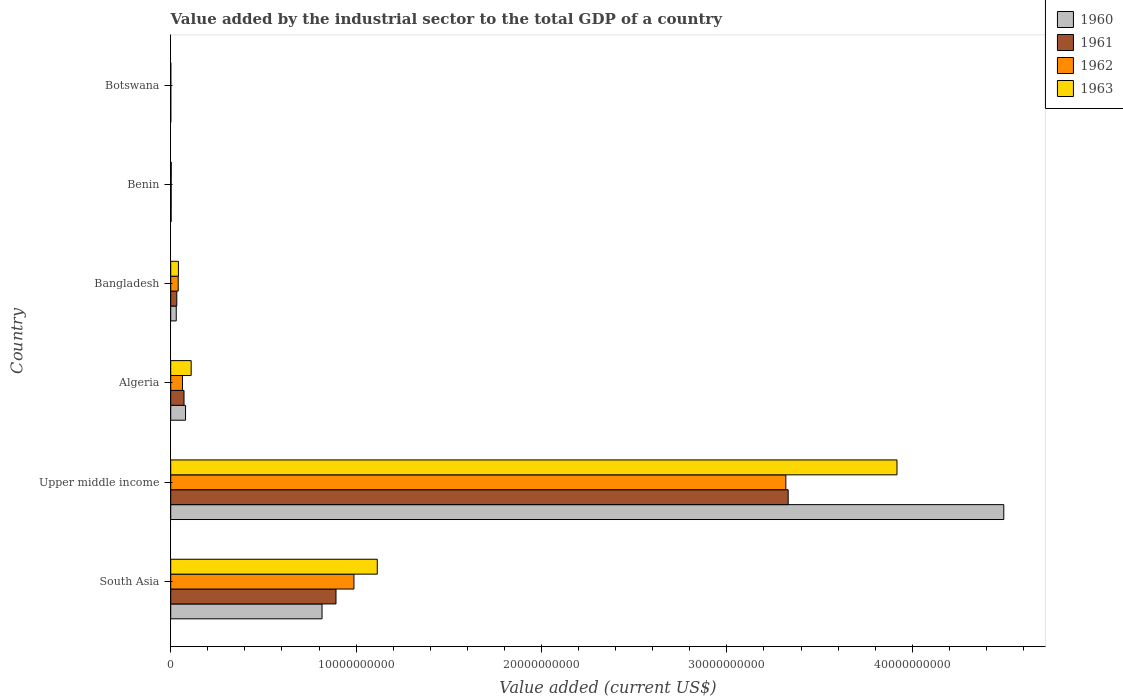How many different coloured bars are there?
Ensure brevity in your answer.  4. How many groups of bars are there?
Your answer should be compact. 6. Are the number of bars per tick equal to the number of legend labels?
Keep it short and to the point. Yes. Are the number of bars on each tick of the Y-axis equal?
Provide a short and direct response. Yes. How many bars are there on the 6th tick from the bottom?
Ensure brevity in your answer.  4. What is the value added by the industrial sector to the total GDP in 1963 in Bangladesh?
Make the answer very short. 4.15e+08. Across all countries, what is the maximum value added by the industrial sector to the total GDP in 1962?
Provide a succinct answer. 3.32e+1. Across all countries, what is the minimum value added by the industrial sector to the total GDP in 1962?
Your answer should be very brief. 4.05e+06. In which country was the value added by the industrial sector to the total GDP in 1960 maximum?
Your answer should be very brief. Upper middle income. In which country was the value added by the industrial sector to the total GDP in 1962 minimum?
Offer a terse response. Botswana. What is the total value added by the industrial sector to the total GDP in 1962 in the graph?
Your response must be concise. 4.41e+1. What is the difference between the value added by the industrial sector to the total GDP in 1963 in South Asia and that in Upper middle income?
Offer a very short reply. -2.80e+1. What is the difference between the value added by the industrial sector to the total GDP in 1963 in South Asia and the value added by the industrial sector to the total GDP in 1962 in Algeria?
Give a very brief answer. 1.05e+1. What is the average value added by the industrial sector to the total GDP in 1961 per country?
Your response must be concise. 7.22e+09. What is the difference between the value added by the industrial sector to the total GDP in 1961 and value added by the industrial sector to the total GDP in 1962 in Botswana?
Give a very brief answer. -8106.08. In how many countries, is the value added by the industrial sector to the total GDP in 1961 greater than 26000000000 US$?
Provide a short and direct response. 1. What is the ratio of the value added by the industrial sector to the total GDP in 1963 in Algeria to that in South Asia?
Offer a very short reply. 0.1. Is the value added by the industrial sector to the total GDP in 1962 in South Asia less than that in Upper middle income?
Offer a very short reply. Yes. What is the difference between the highest and the second highest value added by the industrial sector to the total GDP in 1962?
Keep it short and to the point. 2.33e+1. What is the difference between the highest and the lowest value added by the industrial sector to the total GDP in 1960?
Your answer should be very brief. 4.49e+1. In how many countries, is the value added by the industrial sector to the total GDP in 1962 greater than the average value added by the industrial sector to the total GDP in 1962 taken over all countries?
Ensure brevity in your answer.  2. Is it the case that in every country, the sum of the value added by the industrial sector to the total GDP in 1962 and value added by the industrial sector to the total GDP in 1961 is greater than the sum of value added by the industrial sector to the total GDP in 1963 and value added by the industrial sector to the total GDP in 1960?
Offer a terse response. No. What does the 2nd bar from the bottom in Botswana represents?
Offer a very short reply. 1961. How many bars are there?
Provide a short and direct response. 24. Are all the bars in the graph horizontal?
Provide a succinct answer. Yes. Does the graph contain any zero values?
Keep it short and to the point. No. How many legend labels are there?
Offer a very short reply. 4. What is the title of the graph?
Make the answer very short. Value added by the industrial sector to the total GDP of a country. What is the label or title of the X-axis?
Your answer should be very brief. Value added (current US$). What is the Value added (current US$) of 1960 in South Asia?
Make the answer very short. 8.16e+09. What is the Value added (current US$) in 1961 in South Asia?
Give a very brief answer. 8.91e+09. What is the Value added (current US$) of 1962 in South Asia?
Keep it short and to the point. 9.88e+09. What is the Value added (current US$) of 1963 in South Asia?
Offer a terse response. 1.11e+1. What is the Value added (current US$) of 1960 in Upper middle income?
Offer a terse response. 4.49e+1. What is the Value added (current US$) in 1961 in Upper middle income?
Ensure brevity in your answer.  3.33e+1. What is the Value added (current US$) in 1962 in Upper middle income?
Make the answer very short. 3.32e+1. What is the Value added (current US$) of 1963 in Upper middle income?
Your answer should be compact. 3.92e+1. What is the Value added (current US$) in 1960 in Algeria?
Give a very brief answer. 8.00e+08. What is the Value added (current US$) in 1961 in Algeria?
Ensure brevity in your answer.  7.17e+08. What is the Value added (current US$) of 1962 in Algeria?
Keep it short and to the point. 6.34e+08. What is the Value added (current US$) in 1963 in Algeria?
Make the answer very short. 1.10e+09. What is the Value added (current US$) in 1960 in Bangladesh?
Your answer should be compact. 2.98e+08. What is the Value added (current US$) in 1961 in Bangladesh?
Ensure brevity in your answer.  3.27e+08. What is the Value added (current US$) in 1962 in Bangladesh?
Offer a terse response. 4.05e+08. What is the Value added (current US$) in 1963 in Bangladesh?
Offer a very short reply. 4.15e+08. What is the Value added (current US$) in 1960 in Benin?
Ensure brevity in your answer.  2.31e+07. What is the Value added (current US$) of 1961 in Benin?
Provide a succinct answer. 2.31e+07. What is the Value added (current US$) in 1962 in Benin?
Give a very brief answer. 2.32e+07. What is the Value added (current US$) of 1963 in Benin?
Give a very brief answer. 2.91e+07. What is the Value added (current US$) in 1960 in Botswana?
Your response must be concise. 4.05e+06. What is the Value added (current US$) of 1961 in Botswana?
Your answer should be compact. 4.05e+06. What is the Value added (current US$) in 1962 in Botswana?
Provide a succinct answer. 4.05e+06. What is the Value added (current US$) of 1963 in Botswana?
Ensure brevity in your answer.  4.04e+06. Across all countries, what is the maximum Value added (current US$) in 1960?
Provide a succinct answer. 4.49e+1. Across all countries, what is the maximum Value added (current US$) of 1961?
Make the answer very short. 3.33e+1. Across all countries, what is the maximum Value added (current US$) in 1962?
Offer a terse response. 3.32e+1. Across all countries, what is the maximum Value added (current US$) in 1963?
Give a very brief answer. 3.92e+1. Across all countries, what is the minimum Value added (current US$) of 1960?
Give a very brief answer. 4.05e+06. Across all countries, what is the minimum Value added (current US$) of 1961?
Make the answer very short. 4.05e+06. Across all countries, what is the minimum Value added (current US$) of 1962?
Make the answer very short. 4.05e+06. Across all countries, what is the minimum Value added (current US$) of 1963?
Offer a terse response. 4.04e+06. What is the total Value added (current US$) of 1960 in the graph?
Give a very brief answer. 5.42e+1. What is the total Value added (current US$) of 1961 in the graph?
Provide a short and direct response. 4.33e+1. What is the total Value added (current US$) of 1962 in the graph?
Ensure brevity in your answer.  4.41e+1. What is the total Value added (current US$) of 1963 in the graph?
Provide a succinct answer. 5.19e+1. What is the difference between the Value added (current US$) of 1960 in South Asia and that in Upper middle income?
Your answer should be compact. -3.68e+1. What is the difference between the Value added (current US$) of 1961 in South Asia and that in Upper middle income?
Keep it short and to the point. -2.44e+1. What is the difference between the Value added (current US$) in 1962 in South Asia and that in Upper middle income?
Your answer should be very brief. -2.33e+1. What is the difference between the Value added (current US$) in 1963 in South Asia and that in Upper middle income?
Provide a succinct answer. -2.80e+1. What is the difference between the Value added (current US$) in 1960 in South Asia and that in Algeria?
Your answer should be compact. 7.36e+09. What is the difference between the Value added (current US$) in 1961 in South Asia and that in Algeria?
Provide a succinct answer. 8.20e+09. What is the difference between the Value added (current US$) of 1962 in South Asia and that in Algeria?
Your answer should be very brief. 9.25e+09. What is the difference between the Value added (current US$) in 1963 in South Asia and that in Algeria?
Give a very brief answer. 1.00e+1. What is the difference between the Value added (current US$) of 1960 in South Asia and that in Bangladesh?
Your answer should be very brief. 7.86e+09. What is the difference between the Value added (current US$) in 1961 in South Asia and that in Bangladesh?
Your response must be concise. 8.59e+09. What is the difference between the Value added (current US$) in 1962 in South Asia and that in Bangladesh?
Provide a succinct answer. 9.48e+09. What is the difference between the Value added (current US$) of 1963 in South Asia and that in Bangladesh?
Your response must be concise. 1.07e+1. What is the difference between the Value added (current US$) in 1960 in South Asia and that in Benin?
Ensure brevity in your answer.  8.14e+09. What is the difference between the Value added (current US$) in 1961 in South Asia and that in Benin?
Keep it short and to the point. 8.89e+09. What is the difference between the Value added (current US$) of 1962 in South Asia and that in Benin?
Keep it short and to the point. 9.86e+09. What is the difference between the Value added (current US$) of 1963 in South Asia and that in Benin?
Provide a short and direct response. 1.11e+1. What is the difference between the Value added (current US$) in 1960 in South Asia and that in Botswana?
Give a very brief answer. 8.16e+09. What is the difference between the Value added (current US$) of 1961 in South Asia and that in Botswana?
Provide a succinct answer. 8.91e+09. What is the difference between the Value added (current US$) in 1962 in South Asia and that in Botswana?
Provide a short and direct response. 9.88e+09. What is the difference between the Value added (current US$) of 1963 in South Asia and that in Botswana?
Offer a very short reply. 1.11e+1. What is the difference between the Value added (current US$) of 1960 in Upper middle income and that in Algeria?
Provide a succinct answer. 4.41e+1. What is the difference between the Value added (current US$) in 1961 in Upper middle income and that in Algeria?
Keep it short and to the point. 3.26e+1. What is the difference between the Value added (current US$) of 1962 in Upper middle income and that in Algeria?
Your response must be concise. 3.25e+1. What is the difference between the Value added (current US$) of 1963 in Upper middle income and that in Algeria?
Ensure brevity in your answer.  3.81e+1. What is the difference between the Value added (current US$) of 1960 in Upper middle income and that in Bangladesh?
Offer a very short reply. 4.46e+1. What is the difference between the Value added (current US$) of 1961 in Upper middle income and that in Bangladesh?
Your answer should be very brief. 3.30e+1. What is the difference between the Value added (current US$) of 1962 in Upper middle income and that in Bangladesh?
Your answer should be compact. 3.28e+1. What is the difference between the Value added (current US$) in 1963 in Upper middle income and that in Bangladesh?
Give a very brief answer. 3.88e+1. What is the difference between the Value added (current US$) of 1960 in Upper middle income and that in Benin?
Offer a very short reply. 4.49e+1. What is the difference between the Value added (current US$) in 1961 in Upper middle income and that in Benin?
Your answer should be compact. 3.33e+1. What is the difference between the Value added (current US$) in 1962 in Upper middle income and that in Benin?
Make the answer very short. 3.32e+1. What is the difference between the Value added (current US$) in 1963 in Upper middle income and that in Benin?
Provide a short and direct response. 3.91e+1. What is the difference between the Value added (current US$) of 1960 in Upper middle income and that in Botswana?
Give a very brief answer. 4.49e+1. What is the difference between the Value added (current US$) of 1961 in Upper middle income and that in Botswana?
Make the answer very short. 3.33e+1. What is the difference between the Value added (current US$) of 1962 in Upper middle income and that in Botswana?
Ensure brevity in your answer.  3.32e+1. What is the difference between the Value added (current US$) in 1963 in Upper middle income and that in Botswana?
Offer a terse response. 3.92e+1. What is the difference between the Value added (current US$) in 1960 in Algeria and that in Bangladesh?
Offer a terse response. 5.02e+08. What is the difference between the Value added (current US$) of 1961 in Algeria and that in Bangladesh?
Your answer should be very brief. 3.90e+08. What is the difference between the Value added (current US$) of 1962 in Algeria and that in Bangladesh?
Your response must be concise. 2.30e+08. What is the difference between the Value added (current US$) in 1963 in Algeria and that in Bangladesh?
Offer a terse response. 6.88e+08. What is the difference between the Value added (current US$) of 1960 in Algeria and that in Benin?
Provide a succinct answer. 7.77e+08. What is the difference between the Value added (current US$) of 1961 in Algeria and that in Benin?
Provide a short and direct response. 6.94e+08. What is the difference between the Value added (current US$) of 1962 in Algeria and that in Benin?
Offer a terse response. 6.11e+08. What is the difference between the Value added (current US$) of 1963 in Algeria and that in Benin?
Your answer should be very brief. 1.07e+09. What is the difference between the Value added (current US$) of 1960 in Algeria and that in Botswana?
Your answer should be compact. 7.96e+08. What is the difference between the Value added (current US$) in 1961 in Algeria and that in Botswana?
Provide a succinct answer. 7.13e+08. What is the difference between the Value added (current US$) in 1962 in Algeria and that in Botswana?
Offer a very short reply. 6.30e+08. What is the difference between the Value added (current US$) of 1963 in Algeria and that in Botswana?
Ensure brevity in your answer.  1.10e+09. What is the difference between the Value added (current US$) in 1960 in Bangladesh and that in Benin?
Ensure brevity in your answer.  2.75e+08. What is the difference between the Value added (current US$) in 1961 in Bangladesh and that in Benin?
Your answer should be compact. 3.04e+08. What is the difference between the Value added (current US$) in 1962 in Bangladesh and that in Benin?
Your answer should be compact. 3.82e+08. What is the difference between the Value added (current US$) in 1963 in Bangladesh and that in Benin?
Offer a terse response. 3.86e+08. What is the difference between the Value added (current US$) of 1960 in Bangladesh and that in Botswana?
Keep it short and to the point. 2.94e+08. What is the difference between the Value added (current US$) in 1961 in Bangladesh and that in Botswana?
Provide a succinct answer. 3.23e+08. What is the difference between the Value added (current US$) of 1962 in Bangladesh and that in Botswana?
Offer a very short reply. 4.01e+08. What is the difference between the Value added (current US$) of 1963 in Bangladesh and that in Botswana?
Ensure brevity in your answer.  4.11e+08. What is the difference between the Value added (current US$) in 1960 in Benin and that in Botswana?
Provide a short and direct response. 1.91e+07. What is the difference between the Value added (current US$) in 1961 in Benin and that in Botswana?
Make the answer very short. 1.91e+07. What is the difference between the Value added (current US$) of 1962 in Benin and that in Botswana?
Offer a terse response. 1.91e+07. What is the difference between the Value added (current US$) in 1963 in Benin and that in Botswana?
Offer a very short reply. 2.51e+07. What is the difference between the Value added (current US$) of 1960 in South Asia and the Value added (current US$) of 1961 in Upper middle income?
Your response must be concise. -2.51e+1. What is the difference between the Value added (current US$) in 1960 in South Asia and the Value added (current US$) in 1962 in Upper middle income?
Make the answer very short. -2.50e+1. What is the difference between the Value added (current US$) in 1960 in South Asia and the Value added (current US$) in 1963 in Upper middle income?
Your response must be concise. -3.10e+1. What is the difference between the Value added (current US$) in 1961 in South Asia and the Value added (current US$) in 1962 in Upper middle income?
Give a very brief answer. -2.43e+1. What is the difference between the Value added (current US$) in 1961 in South Asia and the Value added (current US$) in 1963 in Upper middle income?
Keep it short and to the point. -3.03e+1. What is the difference between the Value added (current US$) of 1962 in South Asia and the Value added (current US$) of 1963 in Upper middle income?
Provide a succinct answer. -2.93e+1. What is the difference between the Value added (current US$) of 1960 in South Asia and the Value added (current US$) of 1961 in Algeria?
Offer a terse response. 7.44e+09. What is the difference between the Value added (current US$) of 1960 in South Asia and the Value added (current US$) of 1962 in Algeria?
Keep it short and to the point. 7.53e+09. What is the difference between the Value added (current US$) of 1960 in South Asia and the Value added (current US$) of 1963 in Algeria?
Offer a very short reply. 7.06e+09. What is the difference between the Value added (current US$) of 1961 in South Asia and the Value added (current US$) of 1962 in Algeria?
Provide a succinct answer. 8.28e+09. What is the difference between the Value added (current US$) in 1961 in South Asia and the Value added (current US$) in 1963 in Algeria?
Offer a very short reply. 7.81e+09. What is the difference between the Value added (current US$) of 1962 in South Asia and the Value added (current US$) of 1963 in Algeria?
Keep it short and to the point. 8.78e+09. What is the difference between the Value added (current US$) in 1960 in South Asia and the Value added (current US$) in 1961 in Bangladesh?
Provide a short and direct response. 7.83e+09. What is the difference between the Value added (current US$) in 1960 in South Asia and the Value added (current US$) in 1962 in Bangladesh?
Provide a short and direct response. 7.76e+09. What is the difference between the Value added (current US$) in 1960 in South Asia and the Value added (current US$) in 1963 in Bangladesh?
Offer a terse response. 7.75e+09. What is the difference between the Value added (current US$) of 1961 in South Asia and the Value added (current US$) of 1962 in Bangladesh?
Your answer should be compact. 8.51e+09. What is the difference between the Value added (current US$) of 1961 in South Asia and the Value added (current US$) of 1963 in Bangladesh?
Offer a very short reply. 8.50e+09. What is the difference between the Value added (current US$) in 1962 in South Asia and the Value added (current US$) in 1963 in Bangladesh?
Your response must be concise. 9.47e+09. What is the difference between the Value added (current US$) of 1960 in South Asia and the Value added (current US$) of 1961 in Benin?
Keep it short and to the point. 8.14e+09. What is the difference between the Value added (current US$) in 1960 in South Asia and the Value added (current US$) in 1962 in Benin?
Offer a very short reply. 8.14e+09. What is the difference between the Value added (current US$) in 1960 in South Asia and the Value added (current US$) in 1963 in Benin?
Give a very brief answer. 8.13e+09. What is the difference between the Value added (current US$) in 1961 in South Asia and the Value added (current US$) in 1962 in Benin?
Your answer should be very brief. 8.89e+09. What is the difference between the Value added (current US$) in 1961 in South Asia and the Value added (current US$) in 1963 in Benin?
Keep it short and to the point. 8.89e+09. What is the difference between the Value added (current US$) in 1962 in South Asia and the Value added (current US$) in 1963 in Benin?
Provide a short and direct response. 9.85e+09. What is the difference between the Value added (current US$) of 1960 in South Asia and the Value added (current US$) of 1961 in Botswana?
Offer a terse response. 8.16e+09. What is the difference between the Value added (current US$) in 1960 in South Asia and the Value added (current US$) in 1962 in Botswana?
Your answer should be very brief. 8.16e+09. What is the difference between the Value added (current US$) in 1960 in South Asia and the Value added (current US$) in 1963 in Botswana?
Give a very brief answer. 8.16e+09. What is the difference between the Value added (current US$) of 1961 in South Asia and the Value added (current US$) of 1962 in Botswana?
Your answer should be compact. 8.91e+09. What is the difference between the Value added (current US$) of 1961 in South Asia and the Value added (current US$) of 1963 in Botswana?
Your response must be concise. 8.91e+09. What is the difference between the Value added (current US$) in 1962 in South Asia and the Value added (current US$) in 1963 in Botswana?
Your answer should be compact. 9.88e+09. What is the difference between the Value added (current US$) of 1960 in Upper middle income and the Value added (current US$) of 1961 in Algeria?
Offer a very short reply. 4.42e+1. What is the difference between the Value added (current US$) of 1960 in Upper middle income and the Value added (current US$) of 1962 in Algeria?
Offer a very short reply. 4.43e+1. What is the difference between the Value added (current US$) in 1960 in Upper middle income and the Value added (current US$) in 1963 in Algeria?
Make the answer very short. 4.38e+1. What is the difference between the Value added (current US$) in 1961 in Upper middle income and the Value added (current US$) in 1962 in Algeria?
Your response must be concise. 3.27e+1. What is the difference between the Value added (current US$) in 1961 in Upper middle income and the Value added (current US$) in 1963 in Algeria?
Your answer should be very brief. 3.22e+1. What is the difference between the Value added (current US$) of 1962 in Upper middle income and the Value added (current US$) of 1963 in Algeria?
Your answer should be very brief. 3.21e+1. What is the difference between the Value added (current US$) of 1960 in Upper middle income and the Value added (current US$) of 1961 in Bangladesh?
Provide a short and direct response. 4.46e+1. What is the difference between the Value added (current US$) of 1960 in Upper middle income and the Value added (current US$) of 1962 in Bangladesh?
Keep it short and to the point. 4.45e+1. What is the difference between the Value added (current US$) in 1960 in Upper middle income and the Value added (current US$) in 1963 in Bangladesh?
Make the answer very short. 4.45e+1. What is the difference between the Value added (current US$) of 1961 in Upper middle income and the Value added (current US$) of 1962 in Bangladesh?
Ensure brevity in your answer.  3.29e+1. What is the difference between the Value added (current US$) in 1961 in Upper middle income and the Value added (current US$) in 1963 in Bangladesh?
Provide a short and direct response. 3.29e+1. What is the difference between the Value added (current US$) of 1962 in Upper middle income and the Value added (current US$) of 1963 in Bangladesh?
Make the answer very short. 3.28e+1. What is the difference between the Value added (current US$) of 1960 in Upper middle income and the Value added (current US$) of 1961 in Benin?
Offer a very short reply. 4.49e+1. What is the difference between the Value added (current US$) of 1960 in Upper middle income and the Value added (current US$) of 1962 in Benin?
Make the answer very short. 4.49e+1. What is the difference between the Value added (current US$) in 1960 in Upper middle income and the Value added (current US$) in 1963 in Benin?
Your response must be concise. 4.49e+1. What is the difference between the Value added (current US$) in 1961 in Upper middle income and the Value added (current US$) in 1962 in Benin?
Provide a succinct answer. 3.33e+1. What is the difference between the Value added (current US$) in 1961 in Upper middle income and the Value added (current US$) in 1963 in Benin?
Offer a terse response. 3.33e+1. What is the difference between the Value added (current US$) of 1962 in Upper middle income and the Value added (current US$) of 1963 in Benin?
Your answer should be very brief. 3.31e+1. What is the difference between the Value added (current US$) of 1960 in Upper middle income and the Value added (current US$) of 1961 in Botswana?
Your answer should be very brief. 4.49e+1. What is the difference between the Value added (current US$) of 1960 in Upper middle income and the Value added (current US$) of 1962 in Botswana?
Provide a succinct answer. 4.49e+1. What is the difference between the Value added (current US$) in 1960 in Upper middle income and the Value added (current US$) in 1963 in Botswana?
Make the answer very short. 4.49e+1. What is the difference between the Value added (current US$) of 1961 in Upper middle income and the Value added (current US$) of 1962 in Botswana?
Offer a very short reply. 3.33e+1. What is the difference between the Value added (current US$) in 1961 in Upper middle income and the Value added (current US$) in 1963 in Botswana?
Your answer should be very brief. 3.33e+1. What is the difference between the Value added (current US$) in 1962 in Upper middle income and the Value added (current US$) in 1963 in Botswana?
Your response must be concise. 3.32e+1. What is the difference between the Value added (current US$) in 1960 in Algeria and the Value added (current US$) in 1961 in Bangladesh?
Provide a succinct answer. 4.73e+08. What is the difference between the Value added (current US$) of 1960 in Algeria and the Value added (current US$) of 1962 in Bangladesh?
Make the answer very short. 3.95e+08. What is the difference between the Value added (current US$) in 1960 in Algeria and the Value added (current US$) in 1963 in Bangladesh?
Offer a very short reply. 3.85e+08. What is the difference between the Value added (current US$) in 1961 in Algeria and the Value added (current US$) in 1962 in Bangladesh?
Your response must be concise. 3.12e+08. What is the difference between the Value added (current US$) of 1961 in Algeria and the Value added (current US$) of 1963 in Bangladesh?
Make the answer very short. 3.02e+08. What is the difference between the Value added (current US$) of 1962 in Algeria and the Value added (current US$) of 1963 in Bangladesh?
Provide a short and direct response. 2.19e+08. What is the difference between the Value added (current US$) in 1960 in Algeria and the Value added (current US$) in 1961 in Benin?
Offer a very short reply. 7.77e+08. What is the difference between the Value added (current US$) in 1960 in Algeria and the Value added (current US$) in 1962 in Benin?
Keep it short and to the point. 7.77e+08. What is the difference between the Value added (current US$) of 1960 in Algeria and the Value added (current US$) of 1963 in Benin?
Provide a short and direct response. 7.71e+08. What is the difference between the Value added (current US$) of 1961 in Algeria and the Value added (current US$) of 1962 in Benin?
Your answer should be very brief. 6.94e+08. What is the difference between the Value added (current US$) in 1961 in Algeria and the Value added (current US$) in 1963 in Benin?
Keep it short and to the point. 6.88e+08. What is the difference between the Value added (current US$) in 1962 in Algeria and the Value added (current US$) in 1963 in Benin?
Ensure brevity in your answer.  6.05e+08. What is the difference between the Value added (current US$) of 1960 in Algeria and the Value added (current US$) of 1961 in Botswana?
Ensure brevity in your answer.  7.96e+08. What is the difference between the Value added (current US$) of 1960 in Algeria and the Value added (current US$) of 1962 in Botswana?
Your response must be concise. 7.96e+08. What is the difference between the Value added (current US$) of 1960 in Algeria and the Value added (current US$) of 1963 in Botswana?
Ensure brevity in your answer.  7.96e+08. What is the difference between the Value added (current US$) of 1961 in Algeria and the Value added (current US$) of 1962 in Botswana?
Ensure brevity in your answer.  7.13e+08. What is the difference between the Value added (current US$) in 1961 in Algeria and the Value added (current US$) in 1963 in Botswana?
Provide a succinct answer. 7.13e+08. What is the difference between the Value added (current US$) in 1962 in Algeria and the Value added (current US$) in 1963 in Botswana?
Offer a very short reply. 6.30e+08. What is the difference between the Value added (current US$) of 1960 in Bangladesh and the Value added (current US$) of 1961 in Benin?
Your answer should be very brief. 2.75e+08. What is the difference between the Value added (current US$) in 1960 in Bangladesh and the Value added (current US$) in 1962 in Benin?
Ensure brevity in your answer.  2.75e+08. What is the difference between the Value added (current US$) of 1960 in Bangladesh and the Value added (current US$) of 1963 in Benin?
Your answer should be very brief. 2.69e+08. What is the difference between the Value added (current US$) in 1961 in Bangladesh and the Value added (current US$) in 1962 in Benin?
Offer a very short reply. 3.04e+08. What is the difference between the Value added (current US$) in 1961 in Bangladesh and the Value added (current US$) in 1963 in Benin?
Your answer should be very brief. 2.98e+08. What is the difference between the Value added (current US$) of 1962 in Bangladesh and the Value added (current US$) of 1963 in Benin?
Your answer should be compact. 3.76e+08. What is the difference between the Value added (current US$) in 1960 in Bangladesh and the Value added (current US$) in 1961 in Botswana?
Give a very brief answer. 2.94e+08. What is the difference between the Value added (current US$) in 1960 in Bangladesh and the Value added (current US$) in 1962 in Botswana?
Offer a terse response. 2.94e+08. What is the difference between the Value added (current US$) in 1960 in Bangladesh and the Value added (current US$) in 1963 in Botswana?
Your answer should be compact. 2.94e+08. What is the difference between the Value added (current US$) in 1961 in Bangladesh and the Value added (current US$) in 1962 in Botswana?
Provide a succinct answer. 3.23e+08. What is the difference between the Value added (current US$) in 1961 in Bangladesh and the Value added (current US$) in 1963 in Botswana?
Offer a very short reply. 3.23e+08. What is the difference between the Value added (current US$) in 1962 in Bangladesh and the Value added (current US$) in 1963 in Botswana?
Offer a terse response. 4.01e+08. What is the difference between the Value added (current US$) in 1960 in Benin and the Value added (current US$) in 1961 in Botswana?
Provide a succinct answer. 1.91e+07. What is the difference between the Value added (current US$) in 1960 in Benin and the Value added (current US$) in 1962 in Botswana?
Offer a terse response. 1.91e+07. What is the difference between the Value added (current US$) of 1960 in Benin and the Value added (current US$) of 1963 in Botswana?
Provide a short and direct response. 1.91e+07. What is the difference between the Value added (current US$) of 1961 in Benin and the Value added (current US$) of 1962 in Botswana?
Provide a succinct answer. 1.91e+07. What is the difference between the Value added (current US$) of 1961 in Benin and the Value added (current US$) of 1963 in Botswana?
Your answer should be compact. 1.91e+07. What is the difference between the Value added (current US$) of 1962 in Benin and the Value added (current US$) of 1963 in Botswana?
Provide a short and direct response. 1.91e+07. What is the average Value added (current US$) of 1960 per country?
Your response must be concise. 9.04e+09. What is the average Value added (current US$) in 1961 per country?
Offer a terse response. 7.22e+09. What is the average Value added (current US$) in 1962 per country?
Offer a terse response. 7.35e+09. What is the average Value added (current US$) in 1963 per country?
Your response must be concise. 8.64e+09. What is the difference between the Value added (current US$) of 1960 and Value added (current US$) of 1961 in South Asia?
Your answer should be very brief. -7.53e+08. What is the difference between the Value added (current US$) in 1960 and Value added (current US$) in 1962 in South Asia?
Your answer should be compact. -1.72e+09. What is the difference between the Value added (current US$) of 1960 and Value added (current US$) of 1963 in South Asia?
Provide a short and direct response. -2.98e+09. What is the difference between the Value added (current US$) of 1961 and Value added (current US$) of 1962 in South Asia?
Ensure brevity in your answer.  -9.68e+08. What is the difference between the Value added (current US$) in 1961 and Value added (current US$) in 1963 in South Asia?
Keep it short and to the point. -2.23e+09. What is the difference between the Value added (current US$) of 1962 and Value added (current US$) of 1963 in South Asia?
Your response must be concise. -1.26e+09. What is the difference between the Value added (current US$) of 1960 and Value added (current US$) of 1961 in Upper middle income?
Your answer should be compact. 1.16e+1. What is the difference between the Value added (current US$) in 1960 and Value added (current US$) in 1962 in Upper middle income?
Your response must be concise. 1.18e+1. What is the difference between the Value added (current US$) of 1960 and Value added (current US$) of 1963 in Upper middle income?
Provide a short and direct response. 5.76e+09. What is the difference between the Value added (current US$) of 1961 and Value added (current US$) of 1962 in Upper middle income?
Your answer should be very brief. 1.26e+08. What is the difference between the Value added (current US$) of 1961 and Value added (current US$) of 1963 in Upper middle income?
Your answer should be compact. -5.87e+09. What is the difference between the Value added (current US$) in 1962 and Value added (current US$) in 1963 in Upper middle income?
Offer a very short reply. -5.99e+09. What is the difference between the Value added (current US$) in 1960 and Value added (current US$) in 1961 in Algeria?
Give a very brief answer. 8.27e+07. What is the difference between the Value added (current US$) in 1960 and Value added (current US$) in 1962 in Algeria?
Provide a succinct answer. 1.65e+08. What is the difference between the Value added (current US$) in 1960 and Value added (current US$) in 1963 in Algeria?
Give a very brief answer. -3.03e+08. What is the difference between the Value added (current US$) of 1961 and Value added (current US$) of 1962 in Algeria?
Offer a very short reply. 8.27e+07. What is the difference between the Value added (current US$) in 1961 and Value added (current US$) in 1963 in Algeria?
Ensure brevity in your answer.  -3.86e+08. What is the difference between the Value added (current US$) in 1962 and Value added (current US$) in 1963 in Algeria?
Provide a succinct answer. -4.69e+08. What is the difference between the Value added (current US$) of 1960 and Value added (current US$) of 1961 in Bangladesh?
Your answer should be very brief. -2.92e+07. What is the difference between the Value added (current US$) of 1960 and Value added (current US$) of 1962 in Bangladesh?
Your answer should be very brief. -1.07e+08. What is the difference between the Value added (current US$) of 1960 and Value added (current US$) of 1963 in Bangladesh?
Your answer should be compact. -1.17e+08. What is the difference between the Value added (current US$) in 1961 and Value added (current US$) in 1962 in Bangladesh?
Your answer should be compact. -7.74e+07. What is the difference between the Value added (current US$) of 1961 and Value added (current US$) of 1963 in Bangladesh?
Give a very brief answer. -8.78e+07. What is the difference between the Value added (current US$) of 1962 and Value added (current US$) of 1963 in Bangladesh?
Your answer should be very brief. -1.05e+07. What is the difference between the Value added (current US$) of 1960 and Value added (current US$) of 1961 in Benin?
Provide a succinct answer. 6130.83. What is the difference between the Value added (current US$) of 1960 and Value added (current US$) of 1962 in Benin?
Make the answer very short. -1.71e+04. What is the difference between the Value added (current US$) in 1960 and Value added (current US$) in 1963 in Benin?
Keep it short and to the point. -5.99e+06. What is the difference between the Value added (current US$) of 1961 and Value added (current US$) of 1962 in Benin?
Your answer should be compact. -2.32e+04. What is the difference between the Value added (current US$) of 1961 and Value added (current US$) of 1963 in Benin?
Make the answer very short. -6.00e+06. What is the difference between the Value added (current US$) of 1962 and Value added (current US$) of 1963 in Benin?
Make the answer very short. -5.97e+06. What is the difference between the Value added (current US$) of 1960 and Value added (current US$) of 1961 in Botswana?
Your answer should be very brief. 7791.27. What is the difference between the Value added (current US$) of 1960 and Value added (current US$) of 1962 in Botswana?
Provide a short and direct response. -314.81. What is the difference between the Value added (current US$) in 1960 and Value added (current US$) in 1963 in Botswana?
Make the answer very short. 1.11e+04. What is the difference between the Value added (current US$) in 1961 and Value added (current US$) in 1962 in Botswana?
Keep it short and to the point. -8106.08. What is the difference between the Value added (current US$) in 1961 and Value added (current US$) in 1963 in Botswana?
Your response must be concise. 3353.04. What is the difference between the Value added (current US$) in 1962 and Value added (current US$) in 1963 in Botswana?
Make the answer very short. 1.15e+04. What is the ratio of the Value added (current US$) of 1960 in South Asia to that in Upper middle income?
Make the answer very short. 0.18. What is the ratio of the Value added (current US$) of 1961 in South Asia to that in Upper middle income?
Offer a very short reply. 0.27. What is the ratio of the Value added (current US$) of 1962 in South Asia to that in Upper middle income?
Provide a short and direct response. 0.3. What is the ratio of the Value added (current US$) in 1963 in South Asia to that in Upper middle income?
Offer a very short reply. 0.28. What is the ratio of the Value added (current US$) of 1960 in South Asia to that in Algeria?
Provide a succinct answer. 10.2. What is the ratio of the Value added (current US$) in 1961 in South Asia to that in Algeria?
Your response must be concise. 12.43. What is the ratio of the Value added (current US$) of 1962 in South Asia to that in Algeria?
Provide a short and direct response. 15.58. What is the ratio of the Value added (current US$) in 1963 in South Asia to that in Algeria?
Ensure brevity in your answer.  10.1. What is the ratio of the Value added (current US$) of 1960 in South Asia to that in Bangladesh?
Your answer should be compact. 27.38. What is the ratio of the Value added (current US$) of 1961 in South Asia to that in Bangladesh?
Your response must be concise. 27.24. What is the ratio of the Value added (current US$) of 1962 in South Asia to that in Bangladesh?
Offer a terse response. 24.42. What is the ratio of the Value added (current US$) of 1963 in South Asia to that in Bangladesh?
Provide a short and direct response. 26.84. What is the ratio of the Value added (current US$) in 1960 in South Asia to that in Benin?
Ensure brevity in your answer.  352.83. What is the ratio of the Value added (current US$) of 1961 in South Asia to that in Benin?
Your answer should be compact. 385.47. What is the ratio of the Value added (current US$) in 1962 in South Asia to that in Benin?
Ensure brevity in your answer.  426.89. What is the ratio of the Value added (current US$) of 1963 in South Asia to that in Benin?
Keep it short and to the point. 382.57. What is the ratio of the Value added (current US$) of 1960 in South Asia to that in Botswana?
Ensure brevity in your answer.  2013.33. What is the ratio of the Value added (current US$) in 1961 in South Asia to that in Botswana?
Ensure brevity in your answer.  2203.23. What is the ratio of the Value added (current US$) in 1962 in South Asia to that in Botswana?
Provide a succinct answer. 2437.52. What is the ratio of the Value added (current US$) of 1963 in South Asia to that in Botswana?
Ensure brevity in your answer.  2755.94. What is the ratio of the Value added (current US$) in 1960 in Upper middle income to that in Algeria?
Your answer should be compact. 56.17. What is the ratio of the Value added (current US$) in 1961 in Upper middle income to that in Algeria?
Your answer should be very brief. 46.44. What is the ratio of the Value added (current US$) of 1962 in Upper middle income to that in Algeria?
Make the answer very short. 52.3. What is the ratio of the Value added (current US$) of 1963 in Upper middle income to that in Algeria?
Provide a short and direct response. 35.5. What is the ratio of the Value added (current US$) of 1960 in Upper middle income to that in Bangladesh?
Ensure brevity in your answer.  150.72. What is the ratio of the Value added (current US$) of 1961 in Upper middle income to that in Bangladesh?
Provide a succinct answer. 101.75. What is the ratio of the Value added (current US$) in 1962 in Upper middle income to that in Bangladesh?
Ensure brevity in your answer.  81.99. What is the ratio of the Value added (current US$) in 1963 in Upper middle income to that in Bangladesh?
Ensure brevity in your answer.  94.36. What is the ratio of the Value added (current US$) of 1960 in Upper middle income to that in Benin?
Your answer should be very brief. 1942.42. What is the ratio of the Value added (current US$) in 1961 in Upper middle income to that in Benin?
Offer a very short reply. 1440.1. What is the ratio of the Value added (current US$) of 1962 in Upper middle income to that in Benin?
Provide a succinct answer. 1433.2. What is the ratio of the Value added (current US$) of 1963 in Upper middle income to that in Benin?
Your response must be concise. 1345.05. What is the ratio of the Value added (current US$) in 1960 in Upper middle income to that in Botswana?
Your response must be concise. 1.11e+04. What is the ratio of the Value added (current US$) of 1961 in Upper middle income to that in Botswana?
Give a very brief answer. 8231.16. What is the ratio of the Value added (current US$) of 1962 in Upper middle income to that in Botswana?
Provide a succinct answer. 8183.55. What is the ratio of the Value added (current US$) of 1963 in Upper middle income to that in Botswana?
Give a very brief answer. 9689.55. What is the ratio of the Value added (current US$) in 1960 in Algeria to that in Bangladesh?
Offer a terse response. 2.68. What is the ratio of the Value added (current US$) of 1961 in Algeria to that in Bangladesh?
Offer a terse response. 2.19. What is the ratio of the Value added (current US$) of 1962 in Algeria to that in Bangladesh?
Provide a succinct answer. 1.57. What is the ratio of the Value added (current US$) in 1963 in Algeria to that in Bangladesh?
Offer a terse response. 2.66. What is the ratio of the Value added (current US$) of 1960 in Algeria to that in Benin?
Provide a succinct answer. 34.58. What is the ratio of the Value added (current US$) of 1961 in Algeria to that in Benin?
Your answer should be compact. 31.01. What is the ratio of the Value added (current US$) in 1962 in Algeria to that in Benin?
Provide a succinct answer. 27.4. What is the ratio of the Value added (current US$) in 1963 in Algeria to that in Benin?
Your answer should be compact. 37.88. What is the ratio of the Value added (current US$) of 1960 in Algeria to that in Botswana?
Provide a succinct answer. 197.31. What is the ratio of the Value added (current US$) in 1961 in Algeria to that in Botswana?
Provide a short and direct response. 177.24. What is the ratio of the Value added (current US$) in 1962 in Algeria to that in Botswana?
Keep it short and to the point. 156.48. What is the ratio of the Value added (current US$) of 1963 in Algeria to that in Botswana?
Make the answer very short. 272.91. What is the ratio of the Value added (current US$) of 1960 in Bangladesh to that in Benin?
Your answer should be compact. 12.89. What is the ratio of the Value added (current US$) of 1961 in Bangladesh to that in Benin?
Your answer should be compact. 14.15. What is the ratio of the Value added (current US$) of 1962 in Bangladesh to that in Benin?
Give a very brief answer. 17.48. What is the ratio of the Value added (current US$) in 1963 in Bangladesh to that in Benin?
Keep it short and to the point. 14.26. What is the ratio of the Value added (current US$) in 1960 in Bangladesh to that in Botswana?
Give a very brief answer. 73.54. What is the ratio of the Value added (current US$) in 1961 in Bangladesh to that in Botswana?
Your response must be concise. 80.89. What is the ratio of the Value added (current US$) in 1962 in Bangladesh to that in Botswana?
Your answer should be very brief. 99.81. What is the ratio of the Value added (current US$) of 1963 in Bangladesh to that in Botswana?
Provide a succinct answer. 102.69. What is the ratio of the Value added (current US$) in 1960 in Benin to that in Botswana?
Provide a succinct answer. 5.71. What is the ratio of the Value added (current US$) of 1961 in Benin to that in Botswana?
Give a very brief answer. 5.72. What is the ratio of the Value added (current US$) in 1962 in Benin to that in Botswana?
Offer a very short reply. 5.71. What is the ratio of the Value added (current US$) of 1963 in Benin to that in Botswana?
Give a very brief answer. 7.2. What is the difference between the highest and the second highest Value added (current US$) of 1960?
Provide a short and direct response. 3.68e+1. What is the difference between the highest and the second highest Value added (current US$) of 1961?
Your answer should be compact. 2.44e+1. What is the difference between the highest and the second highest Value added (current US$) of 1962?
Your answer should be compact. 2.33e+1. What is the difference between the highest and the second highest Value added (current US$) in 1963?
Offer a terse response. 2.80e+1. What is the difference between the highest and the lowest Value added (current US$) of 1960?
Your answer should be compact. 4.49e+1. What is the difference between the highest and the lowest Value added (current US$) in 1961?
Your answer should be compact. 3.33e+1. What is the difference between the highest and the lowest Value added (current US$) of 1962?
Offer a terse response. 3.32e+1. What is the difference between the highest and the lowest Value added (current US$) of 1963?
Your response must be concise. 3.92e+1. 